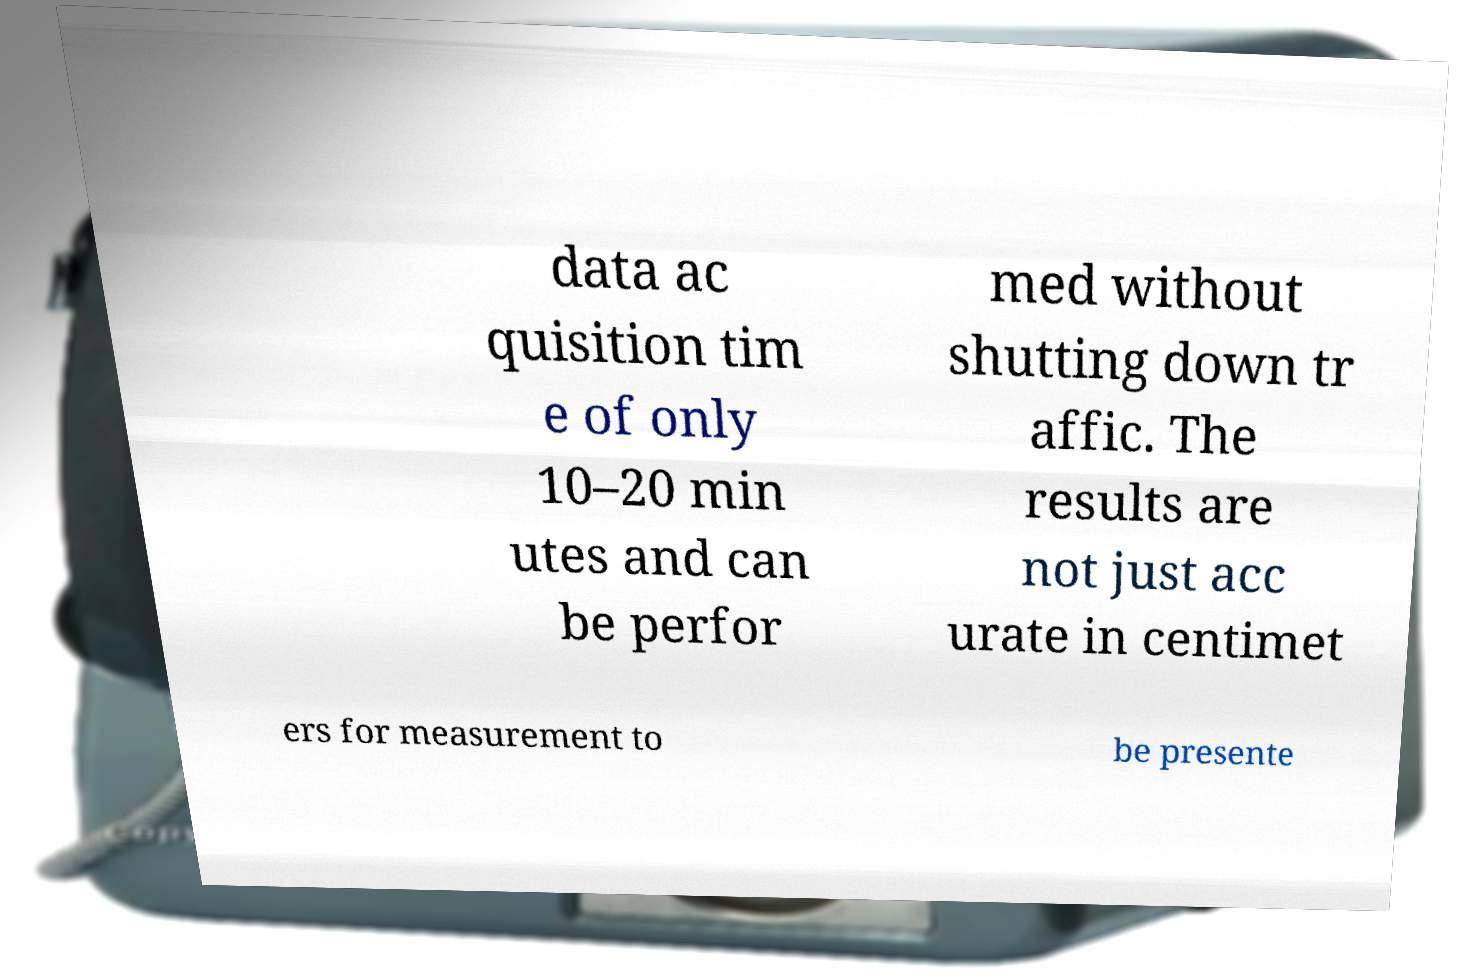Can you read and provide the text displayed in the image?This photo seems to have some interesting text. Can you extract and type it out for me? data ac quisition tim e of only 10–20 min utes and can be perfor med without shutting down tr affic. The results are not just acc urate in centimet ers for measurement to be presente 